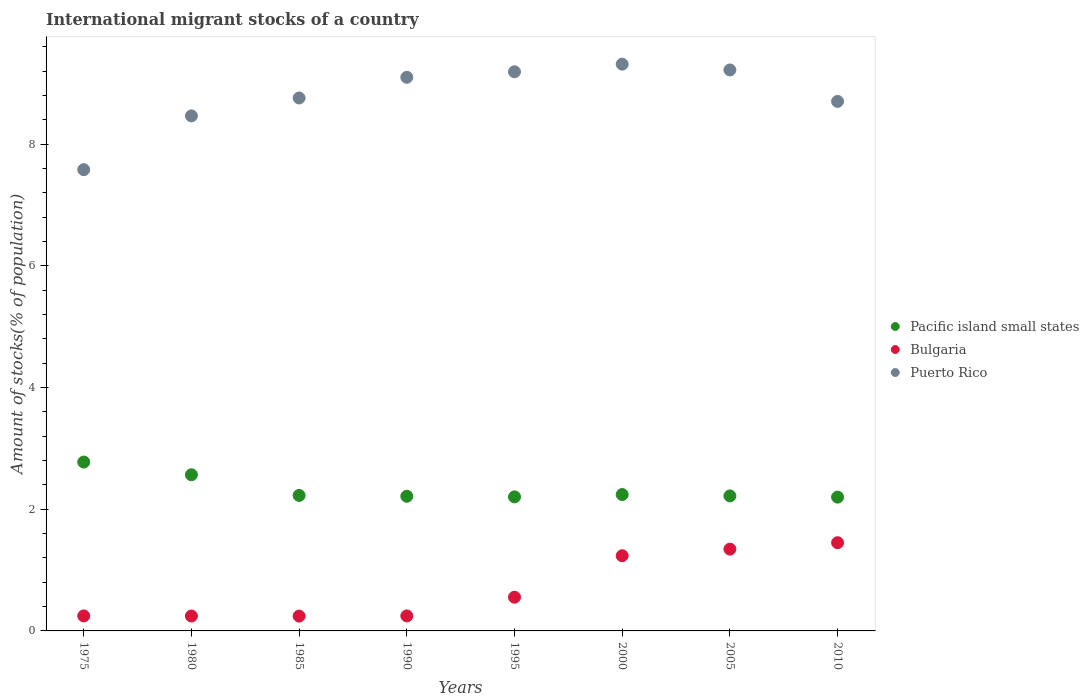How many different coloured dotlines are there?
Provide a succinct answer. 3. What is the amount of stocks in in Puerto Rico in 2000?
Give a very brief answer. 9.32. Across all years, what is the maximum amount of stocks in in Pacific island small states?
Offer a terse response. 2.78. Across all years, what is the minimum amount of stocks in in Pacific island small states?
Your response must be concise. 2.2. In which year was the amount of stocks in in Pacific island small states maximum?
Make the answer very short. 1975. In which year was the amount of stocks in in Bulgaria minimum?
Make the answer very short. 1985. What is the total amount of stocks in in Pacific island small states in the graph?
Provide a succinct answer. 18.65. What is the difference between the amount of stocks in in Puerto Rico in 1995 and that in 2005?
Ensure brevity in your answer.  -0.03. What is the difference between the amount of stocks in in Pacific island small states in 1985 and the amount of stocks in in Puerto Rico in 1995?
Your answer should be very brief. -6.96. What is the average amount of stocks in in Pacific island small states per year?
Make the answer very short. 2.33. In the year 2000, what is the difference between the amount of stocks in in Bulgaria and amount of stocks in in Puerto Rico?
Provide a succinct answer. -8.08. What is the ratio of the amount of stocks in in Puerto Rico in 1990 to that in 1995?
Your response must be concise. 0.99. Is the difference between the amount of stocks in in Bulgaria in 1995 and 2000 greater than the difference between the amount of stocks in in Puerto Rico in 1995 and 2000?
Offer a terse response. No. What is the difference between the highest and the second highest amount of stocks in in Bulgaria?
Provide a succinct answer. 0.11. What is the difference between the highest and the lowest amount of stocks in in Pacific island small states?
Offer a very short reply. 0.58. In how many years, is the amount of stocks in in Bulgaria greater than the average amount of stocks in in Bulgaria taken over all years?
Offer a very short reply. 3. Is it the case that in every year, the sum of the amount of stocks in in Puerto Rico and amount of stocks in in Bulgaria  is greater than the amount of stocks in in Pacific island small states?
Offer a terse response. Yes. Does the amount of stocks in in Puerto Rico monotonically increase over the years?
Your answer should be very brief. No. Is the amount of stocks in in Pacific island small states strictly less than the amount of stocks in in Bulgaria over the years?
Make the answer very short. No. How many dotlines are there?
Provide a succinct answer. 3. Are the values on the major ticks of Y-axis written in scientific E-notation?
Offer a terse response. No. How are the legend labels stacked?
Give a very brief answer. Vertical. What is the title of the graph?
Your response must be concise. International migrant stocks of a country. What is the label or title of the X-axis?
Make the answer very short. Years. What is the label or title of the Y-axis?
Keep it short and to the point. Amount of stocks(% of population). What is the Amount of stocks(% of population) in Pacific island small states in 1975?
Ensure brevity in your answer.  2.78. What is the Amount of stocks(% of population) of Bulgaria in 1975?
Keep it short and to the point. 0.25. What is the Amount of stocks(% of population) in Puerto Rico in 1975?
Your answer should be very brief. 7.58. What is the Amount of stocks(% of population) of Pacific island small states in 1980?
Offer a terse response. 2.57. What is the Amount of stocks(% of population) of Bulgaria in 1980?
Ensure brevity in your answer.  0.24. What is the Amount of stocks(% of population) of Puerto Rico in 1980?
Make the answer very short. 8.47. What is the Amount of stocks(% of population) in Pacific island small states in 1985?
Offer a very short reply. 2.23. What is the Amount of stocks(% of population) of Bulgaria in 1985?
Provide a succinct answer. 0.24. What is the Amount of stocks(% of population) of Puerto Rico in 1985?
Your answer should be compact. 8.76. What is the Amount of stocks(% of population) of Pacific island small states in 1990?
Give a very brief answer. 2.21. What is the Amount of stocks(% of population) in Bulgaria in 1990?
Ensure brevity in your answer.  0.25. What is the Amount of stocks(% of population) in Puerto Rico in 1990?
Your answer should be very brief. 9.1. What is the Amount of stocks(% of population) of Pacific island small states in 1995?
Provide a short and direct response. 2.2. What is the Amount of stocks(% of population) of Bulgaria in 1995?
Your answer should be very brief. 0.55. What is the Amount of stocks(% of population) of Puerto Rico in 1995?
Your answer should be very brief. 9.19. What is the Amount of stocks(% of population) of Pacific island small states in 2000?
Provide a succinct answer. 2.24. What is the Amount of stocks(% of population) of Bulgaria in 2000?
Keep it short and to the point. 1.24. What is the Amount of stocks(% of population) in Puerto Rico in 2000?
Give a very brief answer. 9.32. What is the Amount of stocks(% of population) of Pacific island small states in 2005?
Your answer should be very brief. 2.22. What is the Amount of stocks(% of population) in Bulgaria in 2005?
Your response must be concise. 1.34. What is the Amount of stocks(% of population) in Puerto Rico in 2005?
Provide a succinct answer. 9.22. What is the Amount of stocks(% of population) in Pacific island small states in 2010?
Offer a very short reply. 2.2. What is the Amount of stocks(% of population) of Bulgaria in 2010?
Keep it short and to the point. 1.45. What is the Amount of stocks(% of population) of Puerto Rico in 2010?
Give a very brief answer. 8.71. Across all years, what is the maximum Amount of stocks(% of population) in Pacific island small states?
Ensure brevity in your answer.  2.78. Across all years, what is the maximum Amount of stocks(% of population) of Bulgaria?
Your answer should be very brief. 1.45. Across all years, what is the maximum Amount of stocks(% of population) of Puerto Rico?
Your answer should be very brief. 9.32. Across all years, what is the minimum Amount of stocks(% of population) of Pacific island small states?
Ensure brevity in your answer.  2.2. Across all years, what is the minimum Amount of stocks(% of population) in Bulgaria?
Offer a terse response. 0.24. Across all years, what is the minimum Amount of stocks(% of population) in Puerto Rico?
Provide a short and direct response. 7.58. What is the total Amount of stocks(% of population) of Pacific island small states in the graph?
Ensure brevity in your answer.  18.65. What is the total Amount of stocks(% of population) of Bulgaria in the graph?
Your answer should be compact. 5.57. What is the total Amount of stocks(% of population) in Puerto Rico in the graph?
Ensure brevity in your answer.  70.35. What is the difference between the Amount of stocks(% of population) of Pacific island small states in 1975 and that in 1980?
Give a very brief answer. 0.21. What is the difference between the Amount of stocks(% of population) in Bulgaria in 1975 and that in 1980?
Keep it short and to the point. 0. What is the difference between the Amount of stocks(% of population) of Puerto Rico in 1975 and that in 1980?
Make the answer very short. -0.88. What is the difference between the Amount of stocks(% of population) in Pacific island small states in 1975 and that in 1985?
Provide a short and direct response. 0.55. What is the difference between the Amount of stocks(% of population) in Bulgaria in 1975 and that in 1985?
Keep it short and to the point. 0. What is the difference between the Amount of stocks(% of population) of Puerto Rico in 1975 and that in 1985?
Your answer should be very brief. -1.18. What is the difference between the Amount of stocks(% of population) of Pacific island small states in 1975 and that in 1990?
Provide a succinct answer. 0.56. What is the difference between the Amount of stocks(% of population) in Puerto Rico in 1975 and that in 1990?
Provide a succinct answer. -1.52. What is the difference between the Amount of stocks(% of population) in Pacific island small states in 1975 and that in 1995?
Offer a terse response. 0.57. What is the difference between the Amount of stocks(% of population) in Bulgaria in 1975 and that in 1995?
Provide a succinct answer. -0.31. What is the difference between the Amount of stocks(% of population) of Puerto Rico in 1975 and that in 1995?
Your response must be concise. -1.61. What is the difference between the Amount of stocks(% of population) in Pacific island small states in 1975 and that in 2000?
Offer a terse response. 0.53. What is the difference between the Amount of stocks(% of population) of Bulgaria in 1975 and that in 2000?
Provide a succinct answer. -0.99. What is the difference between the Amount of stocks(% of population) of Puerto Rico in 1975 and that in 2000?
Ensure brevity in your answer.  -1.73. What is the difference between the Amount of stocks(% of population) in Pacific island small states in 1975 and that in 2005?
Make the answer very short. 0.56. What is the difference between the Amount of stocks(% of population) in Bulgaria in 1975 and that in 2005?
Offer a very short reply. -1.1. What is the difference between the Amount of stocks(% of population) of Puerto Rico in 1975 and that in 2005?
Your answer should be very brief. -1.64. What is the difference between the Amount of stocks(% of population) of Pacific island small states in 1975 and that in 2010?
Offer a terse response. 0.58. What is the difference between the Amount of stocks(% of population) of Bulgaria in 1975 and that in 2010?
Offer a very short reply. -1.2. What is the difference between the Amount of stocks(% of population) of Puerto Rico in 1975 and that in 2010?
Keep it short and to the point. -1.12. What is the difference between the Amount of stocks(% of population) in Pacific island small states in 1980 and that in 1985?
Offer a terse response. 0.34. What is the difference between the Amount of stocks(% of population) of Bulgaria in 1980 and that in 1985?
Your response must be concise. 0. What is the difference between the Amount of stocks(% of population) in Puerto Rico in 1980 and that in 1985?
Your response must be concise. -0.29. What is the difference between the Amount of stocks(% of population) in Pacific island small states in 1980 and that in 1990?
Give a very brief answer. 0.35. What is the difference between the Amount of stocks(% of population) in Bulgaria in 1980 and that in 1990?
Provide a short and direct response. -0. What is the difference between the Amount of stocks(% of population) of Puerto Rico in 1980 and that in 1990?
Provide a succinct answer. -0.63. What is the difference between the Amount of stocks(% of population) of Pacific island small states in 1980 and that in 1995?
Your answer should be very brief. 0.36. What is the difference between the Amount of stocks(% of population) in Bulgaria in 1980 and that in 1995?
Offer a very short reply. -0.31. What is the difference between the Amount of stocks(% of population) of Puerto Rico in 1980 and that in 1995?
Your answer should be compact. -0.73. What is the difference between the Amount of stocks(% of population) in Pacific island small states in 1980 and that in 2000?
Provide a succinct answer. 0.33. What is the difference between the Amount of stocks(% of population) in Bulgaria in 1980 and that in 2000?
Your response must be concise. -0.99. What is the difference between the Amount of stocks(% of population) of Puerto Rico in 1980 and that in 2000?
Your answer should be very brief. -0.85. What is the difference between the Amount of stocks(% of population) of Pacific island small states in 1980 and that in 2005?
Provide a short and direct response. 0.35. What is the difference between the Amount of stocks(% of population) in Bulgaria in 1980 and that in 2005?
Keep it short and to the point. -1.1. What is the difference between the Amount of stocks(% of population) in Puerto Rico in 1980 and that in 2005?
Your answer should be compact. -0.76. What is the difference between the Amount of stocks(% of population) in Pacific island small states in 1980 and that in 2010?
Keep it short and to the point. 0.37. What is the difference between the Amount of stocks(% of population) of Bulgaria in 1980 and that in 2010?
Your answer should be compact. -1.21. What is the difference between the Amount of stocks(% of population) in Puerto Rico in 1980 and that in 2010?
Your answer should be compact. -0.24. What is the difference between the Amount of stocks(% of population) of Pacific island small states in 1985 and that in 1990?
Keep it short and to the point. 0.01. What is the difference between the Amount of stocks(% of population) of Bulgaria in 1985 and that in 1990?
Your response must be concise. -0. What is the difference between the Amount of stocks(% of population) of Puerto Rico in 1985 and that in 1990?
Provide a short and direct response. -0.34. What is the difference between the Amount of stocks(% of population) of Pacific island small states in 1985 and that in 1995?
Offer a very short reply. 0.02. What is the difference between the Amount of stocks(% of population) in Bulgaria in 1985 and that in 1995?
Ensure brevity in your answer.  -0.31. What is the difference between the Amount of stocks(% of population) in Puerto Rico in 1985 and that in 1995?
Make the answer very short. -0.43. What is the difference between the Amount of stocks(% of population) of Pacific island small states in 1985 and that in 2000?
Make the answer very short. -0.01. What is the difference between the Amount of stocks(% of population) of Bulgaria in 1985 and that in 2000?
Your answer should be very brief. -0.99. What is the difference between the Amount of stocks(% of population) in Puerto Rico in 1985 and that in 2000?
Ensure brevity in your answer.  -0.56. What is the difference between the Amount of stocks(% of population) of Pacific island small states in 1985 and that in 2005?
Your answer should be compact. 0.01. What is the difference between the Amount of stocks(% of population) in Bulgaria in 1985 and that in 2005?
Your response must be concise. -1.1. What is the difference between the Amount of stocks(% of population) in Puerto Rico in 1985 and that in 2005?
Keep it short and to the point. -0.46. What is the difference between the Amount of stocks(% of population) of Pacific island small states in 1985 and that in 2010?
Your answer should be compact. 0.03. What is the difference between the Amount of stocks(% of population) of Bulgaria in 1985 and that in 2010?
Your response must be concise. -1.21. What is the difference between the Amount of stocks(% of population) of Puerto Rico in 1985 and that in 2010?
Offer a terse response. 0.06. What is the difference between the Amount of stocks(% of population) in Pacific island small states in 1990 and that in 1995?
Keep it short and to the point. 0.01. What is the difference between the Amount of stocks(% of population) of Bulgaria in 1990 and that in 1995?
Provide a succinct answer. -0.31. What is the difference between the Amount of stocks(% of population) in Puerto Rico in 1990 and that in 1995?
Ensure brevity in your answer.  -0.09. What is the difference between the Amount of stocks(% of population) of Pacific island small states in 1990 and that in 2000?
Your response must be concise. -0.03. What is the difference between the Amount of stocks(% of population) in Bulgaria in 1990 and that in 2000?
Provide a short and direct response. -0.99. What is the difference between the Amount of stocks(% of population) of Puerto Rico in 1990 and that in 2000?
Your response must be concise. -0.22. What is the difference between the Amount of stocks(% of population) in Pacific island small states in 1990 and that in 2005?
Your answer should be very brief. -0.01. What is the difference between the Amount of stocks(% of population) in Bulgaria in 1990 and that in 2005?
Provide a short and direct response. -1.1. What is the difference between the Amount of stocks(% of population) of Puerto Rico in 1990 and that in 2005?
Your answer should be very brief. -0.12. What is the difference between the Amount of stocks(% of population) in Pacific island small states in 1990 and that in 2010?
Your answer should be very brief. 0.01. What is the difference between the Amount of stocks(% of population) in Bulgaria in 1990 and that in 2010?
Provide a short and direct response. -1.2. What is the difference between the Amount of stocks(% of population) in Puerto Rico in 1990 and that in 2010?
Keep it short and to the point. 0.4. What is the difference between the Amount of stocks(% of population) of Pacific island small states in 1995 and that in 2000?
Your answer should be very brief. -0.04. What is the difference between the Amount of stocks(% of population) in Bulgaria in 1995 and that in 2000?
Give a very brief answer. -0.68. What is the difference between the Amount of stocks(% of population) in Puerto Rico in 1995 and that in 2000?
Keep it short and to the point. -0.12. What is the difference between the Amount of stocks(% of population) of Pacific island small states in 1995 and that in 2005?
Offer a terse response. -0.02. What is the difference between the Amount of stocks(% of population) in Bulgaria in 1995 and that in 2005?
Offer a terse response. -0.79. What is the difference between the Amount of stocks(% of population) of Puerto Rico in 1995 and that in 2005?
Your response must be concise. -0.03. What is the difference between the Amount of stocks(% of population) of Pacific island small states in 1995 and that in 2010?
Keep it short and to the point. 0. What is the difference between the Amount of stocks(% of population) in Bulgaria in 1995 and that in 2010?
Offer a terse response. -0.9. What is the difference between the Amount of stocks(% of population) in Puerto Rico in 1995 and that in 2010?
Ensure brevity in your answer.  0.49. What is the difference between the Amount of stocks(% of population) in Pacific island small states in 2000 and that in 2005?
Give a very brief answer. 0.02. What is the difference between the Amount of stocks(% of population) of Bulgaria in 2000 and that in 2005?
Your response must be concise. -0.11. What is the difference between the Amount of stocks(% of population) of Puerto Rico in 2000 and that in 2005?
Give a very brief answer. 0.1. What is the difference between the Amount of stocks(% of population) in Pacific island small states in 2000 and that in 2010?
Your answer should be compact. 0.04. What is the difference between the Amount of stocks(% of population) in Bulgaria in 2000 and that in 2010?
Your answer should be compact. -0.21. What is the difference between the Amount of stocks(% of population) in Puerto Rico in 2000 and that in 2010?
Provide a short and direct response. 0.61. What is the difference between the Amount of stocks(% of population) in Pacific island small states in 2005 and that in 2010?
Offer a terse response. 0.02. What is the difference between the Amount of stocks(% of population) of Bulgaria in 2005 and that in 2010?
Offer a terse response. -0.11. What is the difference between the Amount of stocks(% of population) of Puerto Rico in 2005 and that in 2010?
Keep it short and to the point. 0.52. What is the difference between the Amount of stocks(% of population) of Pacific island small states in 1975 and the Amount of stocks(% of population) of Bulgaria in 1980?
Offer a terse response. 2.53. What is the difference between the Amount of stocks(% of population) in Pacific island small states in 1975 and the Amount of stocks(% of population) in Puerto Rico in 1980?
Provide a short and direct response. -5.69. What is the difference between the Amount of stocks(% of population) in Bulgaria in 1975 and the Amount of stocks(% of population) in Puerto Rico in 1980?
Your response must be concise. -8.22. What is the difference between the Amount of stocks(% of population) of Pacific island small states in 1975 and the Amount of stocks(% of population) of Bulgaria in 1985?
Your answer should be very brief. 2.53. What is the difference between the Amount of stocks(% of population) of Pacific island small states in 1975 and the Amount of stocks(% of population) of Puerto Rico in 1985?
Offer a terse response. -5.99. What is the difference between the Amount of stocks(% of population) in Bulgaria in 1975 and the Amount of stocks(% of population) in Puerto Rico in 1985?
Provide a succinct answer. -8.51. What is the difference between the Amount of stocks(% of population) of Pacific island small states in 1975 and the Amount of stocks(% of population) of Bulgaria in 1990?
Give a very brief answer. 2.53. What is the difference between the Amount of stocks(% of population) of Pacific island small states in 1975 and the Amount of stocks(% of population) of Puerto Rico in 1990?
Keep it short and to the point. -6.33. What is the difference between the Amount of stocks(% of population) of Bulgaria in 1975 and the Amount of stocks(% of population) of Puerto Rico in 1990?
Provide a succinct answer. -8.85. What is the difference between the Amount of stocks(% of population) in Pacific island small states in 1975 and the Amount of stocks(% of population) in Bulgaria in 1995?
Offer a terse response. 2.22. What is the difference between the Amount of stocks(% of population) in Pacific island small states in 1975 and the Amount of stocks(% of population) in Puerto Rico in 1995?
Ensure brevity in your answer.  -6.42. What is the difference between the Amount of stocks(% of population) in Bulgaria in 1975 and the Amount of stocks(% of population) in Puerto Rico in 1995?
Provide a short and direct response. -8.95. What is the difference between the Amount of stocks(% of population) in Pacific island small states in 1975 and the Amount of stocks(% of population) in Bulgaria in 2000?
Offer a terse response. 1.54. What is the difference between the Amount of stocks(% of population) in Pacific island small states in 1975 and the Amount of stocks(% of population) in Puerto Rico in 2000?
Your answer should be compact. -6.54. What is the difference between the Amount of stocks(% of population) of Bulgaria in 1975 and the Amount of stocks(% of population) of Puerto Rico in 2000?
Keep it short and to the point. -9.07. What is the difference between the Amount of stocks(% of population) in Pacific island small states in 1975 and the Amount of stocks(% of population) in Bulgaria in 2005?
Keep it short and to the point. 1.43. What is the difference between the Amount of stocks(% of population) in Pacific island small states in 1975 and the Amount of stocks(% of population) in Puerto Rico in 2005?
Keep it short and to the point. -6.45. What is the difference between the Amount of stocks(% of population) of Bulgaria in 1975 and the Amount of stocks(% of population) of Puerto Rico in 2005?
Keep it short and to the point. -8.98. What is the difference between the Amount of stocks(% of population) of Pacific island small states in 1975 and the Amount of stocks(% of population) of Bulgaria in 2010?
Provide a succinct answer. 1.33. What is the difference between the Amount of stocks(% of population) in Pacific island small states in 1975 and the Amount of stocks(% of population) in Puerto Rico in 2010?
Provide a succinct answer. -5.93. What is the difference between the Amount of stocks(% of population) in Bulgaria in 1975 and the Amount of stocks(% of population) in Puerto Rico in 2010?
Ensure brevity in your answer.  -8.46. What is the difference between the Amount of stocks(% of population) in Pacific island small states in 1980 and the Amount of stocks(% of population) in Bulgaria in 1985?
Your answer should be compact. 2.32. What is the difference between the Amount of stocks(% of population) in Pacific island small states in 1980 and the Amount of stocks(% of population) in Puerto Rico in 1985?
Your response must be concise. -6.19. What is the difference between the Amount of stocks(% of population) of Bulgaria in 1980 and the Amount of stocks(% of population) of Puerto Rico in 1985?
Give a very brief answer. -8.52. What is the difference between the Amount of stocks(% of population) in Pacific island small states in 1980 and the Amount of stocks(% of population) in Bulgaria in 1990?
Provide a succinct answer. 2.32. What is the difference between the Amount of stocks(% of population) of Pacific island small states in 1980 and the Amount of stocks(% of population) of Puerto Rico in 1990?
Offer a terse response. -6.53. What is the difference between the Amount of stocks(% of population) in Bulgaria in 1980 and the Amount of stocks(% of population) in Puerto Rico in 1990?
Your response must be concise. -8.86. What is the difference between the Amount of stocks(% of population) in Pacific island small states in 1980 and the Amount of stocks(% of population) in Bulgaria in 1995?
Offer a terse response. 2.01. What is the difference between the Amount of stocks(% of population) in Pacific island small states in 1980 and the Amount of stocks(% of population) in Puerto Rico in 1995?
Provide a succinct answer. -6.62. What is the difference between the Amount of stocks(% of population) in Bulgaria in 1980 and the Amount of stocks(% of population) in Puerto Rico in 1995?
Keep it short and to the point. -8.95. What is the difference between the Amount of stocks(% of population) in Pacific island small states in 1980 and the Amount of stocks(% of population) in Bulgaria in 2000?
Offer a terse response. 1.33. What is the difference between the Amount of stocks(% of population) in Pacific island small states in 1980 and the Amount of stocks(% of population) in Puerto Rico in 2000?
Make the answer very short. -6.75. What is the difference between the Amount of stocks(% of population) in Bulgaria in 1980 and the Amount of stocks(% of population) in Puerto Rico in 2000?
Offer a terse response. -9.07. What is the difference between the Amount of stocks(% of population) of Pacific island small states in 1980 and the Amount of stocks(% of population) of Bulgaria in 2005?
Offer a very short reply. 1.22. What is the difference between the Amount of stocks(% of population) in Pacific island small states in 1980 and the Amount of stocks(% of population) in Puerto Rico in 2005?
Your answer should be very brief. -6.65. What is the difference between the Amount of stocks(% of population) in Bulgaria in 1980 and the Amount of stocks(% of population) in Puerto Rico in 2005?
Your answer should be compact. -8.98. What is the difference between the Amount of stocks(% of population) in Pacific island small states in 1980 and the Amount of stocks(% of population) in Bulgaria in 2010?
Make the answer very short. 1.12. What is the difference between the Amount of stocks(% of population) in Pacific island small states in 1980 and the Amount of stocks(% of population) in Puerto Rico in 2010?
Your response must be concise. -6.14. What is the difference between the Amount of stocks(% of population) in Bulgaria in 1980 and the Amount of stocks(% of population) in Puerto Rico in 2010?
Make the answer very short. -8.46. What is the difference between the Amount of stocks(% of population) of Pacific island small states in 1985 and the Amount of stocks(% of population) of Bulgaria in 1990?
Provide a succinct answer. 1.98. What is the difference between the Amount of stocks(% of population) in Pacific island small states in 1985 and the Amount of stocks(% of population) in Puerto Rico in 1990?
Offer a terse response. -6.87. What is the difference between the Amount of stocks(% of population) of Bulgaria in 1985 and the Amount of stocks(% of population) of Puerto Rico in 1990?
Your answer should be very brief. -8.86. What is the difference between the Amount of stocks(% of population) of Pacific island small states in 1985 and the Amount of stocks(% of population) of Bulgaria in 1995?
Your answer should be very brief. 1.67. What is the difference between the Amount of stocks(% of population) of Pacific island small states in 1985 and the Amount of stocks(% of population) of Puerto Rico in 1995?
Your answer should be compact. -6.96. What is the difference between the Amount of stocks(% of population) of Bulgaria in 1985 and the Amount of stocks(% of population) of Puerto Rico in 1995?
Provide a short and direct response. -8.95. What is the difference between the Amount of stocks(% of population) in Pacific island small states in 1985 and the Amount of stocks(% of population) in Puerto Rico in 2000?
Your response must be concise. -7.09. What is the difference between the Amount of stocks(% of population) of Bulgaria in 1985 and the Amount of stocks(% of population) of Puerto Rico in 2000?
Your answer should be very brief. -9.07. What is the difference between the Amount of stocks(% of population) in Pacific island small states in 1985 and the Amount of stocks(% of population) in Bulgaria in 2005?
Your answer should be very brief. 0.88. What is the difference between the Amount of stocks(% of population) in Pacific island small states in 1985 and the Amount of stocks(% of population) in Puerto Rico in 2005?
Your answer should be very brief. -6.99. What is the difference between the Amount of stocks(% of population) of Bulgaria in 1985 and the Amount of stocks(% of population) of Puerto Rico in 2005?
Ensure brevity in your answer.  -8.98. What is the difference between the Amount of stocks(% of population) of Pacific island small states in 1985 and the Amount of stocks(% of population) of Bulgaria in 2010?
Provide a short and direct response. 0.78. What is the difference between the Amount of stocks(% of population) in Pacific island small states in 1985 and the Amount of stocks(% of population) in Puerto Rico in 2010?
Offer a very short reply. -6.48. What is the difference between the Amount of stocks(% of population) of Bulgaria in 1985 and the Amount of stocks(% of population) of Puerto Rico in 2010?
Provide a succinct answer. -8.46. What is the difference between the Amount of stocks(% of population) in Pacific island small states in 1990 and the Amount of stocks(% of population) in Bulgaria in 1995?
Your response must be concise. 1.66. What is the difference between the Amount of stocks(% of population) in Pacific island small states in 1990 and the Amount of stocks(% of population) in Puerto Rico in 1995?
Provide a succinct answer. -6.98. What is the difference between the Amount of stocks(% of population) in Bulgaria in 1990 and the Amount of stocks(% of population) in Puerto Rico in 1995?
Your response must be concise. -8.95. What is the difference between the Amount of stocks(% of population) in Pacific island small states in 1990 and the Amount of stocks(% of population) in Bulgaria in 2000?
Your response must be concise. 0.98. What is the difference between the Amount of stocks(% of population) of Pacific island small states in 1990 and the Amount of stocks(% of population) of Puerto Rico in 2000?
Keep it short and to the point. -7.1. What is the difference between the Amount of stocks(% of population) in Bulgaria in 1990 and the Amount of stocks(% of population) in Puerto Rico in 2000?
Make the answer very short. -9.07. What is the difference between the Amount of stocks(% of population) in Pacific island small states in 1990 and the Amount of stocks(% of population) in Bulgaria in 2005?
Give a very brief answer. 0.87. What is the difference between the Amount of stocks(% of population) of Pacific island small states in 1990 and the Amount of stocks(% of population) of Puerto Rico in 2005?
Offer a very short reply. -7.01. What is the difference between the Amount of stocks(% of population) of Bulgaria in 1990 and the Amount of stocks(% of population) of Puerto Rico in 2005?
Give a very brief answer. -8.98. What is the difference between the Amount of stocks(% of population) in Pacific island small states in 1990 and the Amount of stocks(% of population) in Bulgaria in 2010?
Ensure brevity in your answer.  0.76. What is the difference between the Amount of stocks(% of population) in Pacific island small states in 1990 and the Amount of stocks(% of population) in Puerto Rico in 2010?
Your answer should be very brief. -6.49. What is the difference between the Amount of stocks(% of population) of Bulgaria in 1990 and the Amount of stocks(% of population) of Puerto Rico in 2010?
Ensure brevity in your answer.  -8.46. What is the difference between the Amount of stocks(% of population) in Pacific island small states in 1995 and the Amount of stocks(% of population) in Bulgaria in 2000?
Keep it short and to the point. 0.97. What is the difference between the Amount of stocks(% of population) in Pacific island small states in 1995 and the Amount of stocks(% of population) in Puerto Rico in 2000?
Make the answer very short. -7.11. What is the difference between the Amount of stocks(% of population) in Bulgaria in 1995 and the Amount of stocks(% of population) in Puerto Rico in 2000?
Your answer should be very brief. -8.76. What is the difference between the Amount of stocks(% of population) in Pacific island small states in 1995 and the Amount of stocks(% of population) in Bulgaria in 2005?
Keep it short and to the point. 0.86. What is the difference between the Amount of stocks(% of population) in Pacific island small states in 1995 and the Amount of stocks(% of population) in Puerto Rico in 2005?
Your response must be concise. -7.02. What is the difference between the Amount of stocks(% of population) of Bulgaria in 1995 and the Amount of stocks(% of population) of Puerto Rico in 2005?
Ensure brevity in your answer.  -8.67. What is the difference between the Amount of stocks(% of population) of Pacific island small states in 1995 and the Amount of stocks(% of population) of Bulgaria in 2010?
Keep it short and to the point. 0.75. What is the difference between the Amount of stocks(% of population) in Pacific island small states in 1995 and the Amount of stocks(% of population) in Puerto Rico in 2010?
Ensure brevity in your answer.  -6.5. What is the difference between the Amount of stocks(% of population) of Bulgaria in 1995 and the Amount of stocks(% of population) of Puerto Rico in 2010?
Offer a very short reply. -8.15. What is the difference between the Amount of stocks(% of population) of Pacific island small states in 2000 and the Amount of stocks(% of population) of Bulgaria in 2005?
Offer a very short reply. 0.9. What is the difference between the Amount of stocks(% of population) of Pacific island small states in 2000 and the Amount of stocks(% of population) of Puerto Rico in 2005?
Make the answer very short. -6.98. What is the difference between the Amount of stocks(% of population) of Bulgaria in 2000 and the Amount of stocks(% of population) of Puerto Rico in 2005?
Your answer should be very brief. -7.99. What is the difference between the Amount of stocks(% of population) of Pacific island small states in 2000 and the Amount of stocks(% of population) of Bulgaria in 2010?
Your answer should be compact. 0.79. What is the difference between the Amount of stocks(% of population) of Pacific island small states in 2000 and the Amount of stocks(% of population) of Puerto Rico in 2010?
Your answer should be compact. -6.46. What is the difference between the Amount of stocks(% of population) in Bulgaria in 2000 and the Amount of stocks(% of population) in Puerto Rico in 2010?
Your response must be concise. -7.47. What is the difference between the Amount of stocks(% of population) in Pacific island small states in 2005 and the Amount of stocks(% of population) in Bulgaria in 2010?
Ensure brevity in your answer.  0.77. What is the difference between the Amount of stocks(% of population) of Pacific island small states in 2005 and the Amount of stocks(% of population) of Puerto Rico in 2010?
Keep it short and to the point. -6.49. What is the difference between the Amount of stocks(% of population) of Bulgaria in 2005 and the Amount of stocks(% of population) of Puerto Rico in 2010?
Offer a terse response. -7.36. What is the average Amount of stocks(% of population) of Pacific island small states per year?
Keep it short and to the point. 2.33. What is the average Amount of stocks(% of population) in Bulgaria per year?
Offer a terse response. 0.7. What is the average Amount of stocks(% of population) of Puerto Rico per year?
Keep it short and to the point. 8.79. In the year 1975, what is the difference between the Amount of stocks(% of population) of Pacific island small states and Amount of stocks(% of population) of Bulgaria?
Make the answer very short. 2.53. In the year 1975, what is the difference between the Amount of stocks(% of population) of Pacific island small states and Amount of stocks(% of population) of Puerto Rico?
Offer a very short reply. -4.81. In the year 1975, what is the difference between the Amount of stocks(% of population) of Bulgaria and Amount of stocks(% of population) of Puerto Rico?
Provide a succinct answer. -7.34. In the year 1980, what is the difference between the Amount of stocks(% of population) of Pacific island small states and Amount of stocks(% of population) of Bulgaria?
Make the answer very short. 2.32. In the year 1980, what is the difference between the Amount of stocks(% of population) in Pacific island small states and Amount of stocks(% of population) in Puerto Rico?
Keep it short and to the point. -5.9. In the year 1980, what is the difference between the Amount of stocks(% of population) in Bulgaria and Amount of stocks(% of population) in Puerto Rico?
Offer a terse response. -8.22. In the year 1985, what is the difference between the Amount of stocks(% of population) of Pacific island small states and Amount of stocks(% of population) of Bulgaria?
Give a very brief answer. 1.98. In the year 1985, what is the difference between the Amount of stocks(% of population) of Pacific island small states and Amount of stocks(% of population) of Puerto Rico?
Give a very brief answer. -6.53. In the year 1985, what is the difference between the Amount of stocks(% of population) of Bulgaria and Amount of stocks(% of population) of Puerto Rico?
Ensure brevity in your answer.  -8.52. In the year 1990, what is the difference between the Amount of stocks(% of population) in Pacific island small states and Amount of stocks(% of population) in Bulgaria?
Your answer should be very brief. 1.97. In the year 1990, what is the difference between the Amount of stocks(% of population) of Pacific island small states and Amount of stocks(% of population) of Puerto Rico?
Keep it short and to the point. -6.89. In the year 1990, what is the difference between the Amount of stocks(% of population) in Bulgaria and Amount of stocks(% of population) in Puerto Rico?
Your answer should be compact. -8.85. In the year 1995, what is the difference between the Amount of stocks(% of population) of Pacific island small states and Amount of stocks(% of population) of Bulgaria?
Your answer should be very brief. 1.65. In the year 1995, what is the difference between the Amount of stocks(% of population) of Pacific island small states and Amount of stocks(% of population) of Puerto Rico?
Your response must be concise. -6.99. In the year 1995, what is the difference between the Amount of stocks(% of population) of Bulgaria and Amount of stocks(% of population) of Puerto Rico?
Your response must be concise. -8.64. In the year 2000, what is the difference between the Amount of stocks(% of population) in Pacific island small states and Amount of stocks(% of population) in Bulgaria?
Give a very brief answer. 1.01. In the year 2000, what is the difference between the Amount of stocks(% of population) in Pacific island small states and Amount of stocks(% of population) in Puerto Rico?
Offer a very short reply. -7.08. In the year 2000, what is the difference between the Amount of stocks(% of population) in Bulgaria and Amount of stocks(% of population) in Puerto Rico?
Provide a short and direct response. -8.08. In the year 2005, what is the difference between the Amount of stocks(% of population) of Pacific island small states and Amount of stocks(% of population) of Bulgaria?
Your answer should be very brief. 0.87. In the year 2005, what is the difference between the Amount of stocks(% of population) in Pacific island small states and Amount of stocks(% of population) in Puerto Rico?
Your response must be concise. -7. In the year 2005, what is the difference between the Amount of stocks(% of population) of Bulgaria and Amount of stocks(% of population) of Puerto Rico?
Offer a terse response. -7.88. In the year 2010, what is the difference between the Amount of stocks(% of population) in Pacific island small states and Amount of stocks(% of population) in Bulgaria?
Give a very brief answer. 0.75. In the year 2010, what is the difference between the Amount of stocks(% of population) of Pacific island small states and Amount of stocks(% of population) of Puerto Rico?
Provide a succinct answer. -6.51. In the year 2010, what is the difference between the Amount of stocks(% of population) of Bulgaria and Amount of stocks(% of population) of Puerto Rico?
Your response must be concise. -7.25. What is the ratio of the Amount of stocks(% of population) in Pacific island small states in 1975 to that in 1980?
Your response must be concise. 1.08. What is the ratio of the Amount of stocks(% of population) of Bulgaria in 1975 to that in 1980?
Provide a short and direct response. 1.01. What is the ratio of the Amount of stocks(% of population) in Puerto Rico in 1975 to that in 1980?
Offer a very short reply. 0.9. What is the ratio of the Amount of stocks(% of population) in Pacific island small states in 1975 to that in 1985?
Offer a very short reply. 1.25. What is the ratio of the Amount of stocks(% of population) of Bulgaria in 1975 to that in 1985?
Provide a succinct answer. 1.01. What is the ratio of the Amount of stocks(% of population) of Puerto Rico in 1975 to that in 1985?
Keep it short and to the point. 0.87. What is the ratio of the Amount of stocks(% of population) of Pacific island small states in 1975 to that in 1990?
Keep it short and to the point. 1.25. What is the ratio of the Amount of stocks(% of population) in Bulgaria in 1975 to that in 1990?
Make the answer very short. 1. What is the ratio of the Amount of stocks(% of population) of Puerto Rico in 1975 to that in 1990?
Offer a terse response. 0.83. What is the ratio of the Amount of stocks(% of population) in Pacific island small states in 1975 to that in 1995?
Keep it short and to the point. 1.26. What is the ratio of the Amount of stocks(% of population) in Bulgaria in 1975 to that in 1995?
Offer a terse response. 0.44. What is the ratio of the Amount of stocks(% of population) of Puerto Rico in 1975 to that in 1995?
Keep it short and to the point. 0.82. What is the ratio of the Amount of stocks(% of population) in Pacific island small states in 1975 to that in 2000?
Your response must be concise. 1.24. What is the ratio of the Amount of stocks(% of population) in Bulgaria in 1975 to that in 2000?
Ensure brevity in your answer.  0.2. What is the ratio of the Amount of stocks(% of population) of Puerto Rico in 1975 to that in 2000?
Give a very brief answer. 0.81. What is the ratio of the Amount of stocks(% of population) of Pacific island small states in 1975 to that in 2005?
Provide a short and direct response. 1.25. What is the ratio of the Amount of stocks(% of population) of Bulgaria in 1975 to that in 2005?
Offer a very short reply. 0.18. What is the ratio of the Amount of stocks(% of population) in Puerto Rico in 1975 to that in 2005?
Keep it short and to the point. 0.82. What is the ratio of the Amount of stocks(% of population) of Pacific island small states in 1975 to that in 2010?
Your response must be concise. 1.26. What is the ratio of the Amount of stocks(% of population) of Bulgaria in 1975 to that in 2010?
Ensure brevity in your answer.  0.17. What is the ratio of the Amount of stocks(% of population) in Puerto Rico in 1975 to that in 2010?
Offer a terse response. 0.87. What is the ratio of the Amount of stocks(% of population) in Pacific island small states in 1980 to that in 1985?
Provide a short and direct response. 1.15. What is the ratio of the Amount of stocks(% of population) in Bulgaria in 1980 to that in 1985?
Keep it short and to the point. 1. What is the ratio of the Amount of stocks(% of population) of Puerto Rico in 1980 to that in 1985?
Your response must be concise. 0.97. What is the ratio of the Amount of stocks(% of population) in Pacific island small states in 1980 to that in 1990?
Keep it short and to the point. 1.16. What is the ratio of the Amount of stocks(% of population) of Bulgaria in 1980 to that in 1990?
Make the answer very short. 0.99. What is the ratio of the Amount of stocks(% of population) of Puerto Rico in 1980 to that in 1990?
Ensure brevity in your answer.  0.93. What is the ratio of the Amount of stocks(% of population) in Pacific island small states in 1980 to that in 1995?
Keep it short and to the point. 1.16. What is the ratio of the Amount of stocks(% of population) in Bulgaria in 1980 to that in 1995?
Keep it short and to the point. 0.44. What is the ratio of the Amount of stocks(% of population) of Puerto Rico in 1980 to that in 1995?
Make the answer very short. 0.92. What is the ratio of the Amount of stocks(% of population) in Pacific island small states in 1980 to that in 2000?
Make the answer very short. 1.15. What is the ratio of the Amount of stocks(% of population) of Bulgaria in 1980 to that in 2000?
Provide a succinct answer. 0.2. What is the ratio of the Amount of stocks(% of population) in Puerto Rico in 1980 to that in 2000?
Provide a succinct answer. 0.91. What is the ratio of the Amount of stocks(% of population) of Pacific island small states in 1980 to that in 2005?
Your answer should be compact. 1.16. What is the ratio of the Amount of stocks(% of population) of Bulgaria in 1980 to that in 2005?
Offer a very short reply. 0.18. What is the ratio of the Amount of stocks(% of population) of Puerto Rico in 1980 to that in 2005?
Ensure brevity in your answer.  0.92. What is the ratio of the Amount of stocks(% of population) of Pacific island small states in 1980 to that in 2010?
Keep it short and to the point. 1.17. What is the ratio of the Amount of stocks(% of population) of Bulgaria in 1980 to that in 2010?
Your response must be concise. 0.17. What is the ratio of the Amount of stocks(% of population) of Puerto Rico in 1980 to that in 2010?
Your answer should be compact. 0.97. What is the ratio of the Amount of stocks(% of population) in Puerto Rico in 1985 to that in 1990?
Provide a succinct answer. 0.96. What is the ratio of the Amount of stocks(% of population) of Pacific island small states in 1985 to that in 1995?
Ensure brevity in your answer.  1.01. What is the ratio of the Amount of stocks(% of population) in Bulgaria in 1985 to that in 1995?
Ensure brevity in your answer.  0.44. What is the ratio of the Amount of stocks(% of population) in Puerto Rico in 1985 to that in 1995?
Offer a terse response. 0.95. What is the ratio of the Amount of stocks(% of population) of Bulgaria in 1985 to that in 2000?
Offer a terse response. 0.2. What is the ratio of the Amount of stocks(% of population) of Puerto Rico in 1985 to that in 2000?
Offer a terse response. 0.94. What is the ratio of the Amount of stocks(% of population) in Pacific island small states in 1985 to that in 2005?
Offer a very short reply. 1. What is the ratio of the Amount of stocks(% of population) of Bulgaria in 1985 to that in 2005?
Keep it short and to the point. 0.18. What is the ratio of the Amount of stocks(% of population) in Puerto Rico in 1985 to that in 2005?
Offer a very short reply. 0.95. What is the ratio of the Amount of stocks(% of population) of Pacific island small states in 1985 to that in 2010?
Offer a very short reply. 1.01. What is the ratio of the Amount of stocks(% of population) in Bulgaria in 1985 to that in 2010?
Offer a terse response. 0.17. What is the ratio of the Amount of stocks(% of population) of Pacific island small states in 1990 to that in 1995?
Make the answer very short. 1. What is the ratio of the Amount of stocks(% of population) in Bulgaria in 1990 to that in 1995?
Keep it short and to the point. 0.45. What is the ratio of the Amount of stocks(% of population) of Puerto Rico in 1990 to that in 1995?
Ensure brevity in your answer.  0.99. What is the ratio of the Amount of stocks(% of population) of Pacific island small states in 1990 to that in 2000?
Give a very brief answer. 0.99. What is the ratio of the Amount of stocks(% of population) in Bulgaria in 1990 to that in 2000?
Ensure brevity in your answer.  0.2. What is the ratio of the Amount of stocks(% of population) of Puerto Rico in 1990 to that in 2000?
Make the answer very short. 0.98. What is the ratio of the Amount of stocks(% of population) in Bulgaria in 1990 to that in 2005?
Your response must be concise. 0.18. What is the ratio of the Amount of stocks(% of population) in Puerto Rico in 1990 to that in 2005?
Keep it short and to the point. 0.99. What is the ratio of the Amount of stocks(% of population) of Pacific island small states in 1990 to that in 2010?
Ensure brevity in your answer.  1.01. What is the ratio of the Amount of stocks(% of population) of Bulgaria in 1990 to that in 2010?
Give a very brief answer. 0.17. What is the ratio of the Amount of stocks(% of population) in Puerto Rico in 1990 to that in 2010?
Make the answer very short. 1.05. What is the ratio of the Amount of stocks(% of population) of Pacific island small states in 1995 to that in 2000?
Provide a short and direct response. 0.98. What is the ratio of the Amount of stocks(% of population) of Bulgaria in 1995 to that in 2000?
Provide a succinct answer. 0.45. What is the ratio of the Amount of stocks(% of population) of Puerto Rico in 1995 to that in 2000?
Provide a succinct answer. 0.99. What is the ratio of the Amount of stocks(% of population) of Bulgaria in 1995 to that in 2005?
Make the answer very short. 0.41. What is the ratio of the Amount of stocks(% of population) of Puerto Rico in 1995 to that in 2005?
Offer a terse response. 1. What is the ratio of the Amount of stocks(% of population) of Bulgaria in 1995 to that in 2010?
Provide a short and direct response. 0.38. What is the ratio of the Amount of stocks(% of population) of Puerto Rico in 1995 to that in 2010?
Keep it short and to the point. 1.06. What is the ratio of the Amount of stocks(% of population) in Pacific island small states in 2000 to that in 2005?
Your answer should be very brief. 1.01. What is the ratio of the Amount of stocks(% of population) of Bulgaria in 2000 to that in 2005?
Keep it short and to the point. 0.92. What is the ratio of the Amount of stocks(% of population) of Puerto Rico in 2000 to that in 2005?
Give a very brief answer. 1.01. What is the ratio of the Amount of stocks(% of population) in Pacific island small states in 2000 to that in 2010?
Keep it short and to the point. 1.02. What is the ratio of the Amount of stocks(% of population) in Bulgaria in 2000 to that in 2010?
Make the answer very short. 0.85. What is the ratio of the Amount of stocks(% of population) in Puerto Rico in 2000 to that in 2010?
Provide a succinct answer. 1.07. What is the ratio of the Amount of stocks(% of population) of Pacific island small states in 2005 to that in 2010?
Your response must be concise. 1.01. What is the ratio of the Amount of stocks(% of population) of Bulgaria in 2005 to that in 2010?
Ensure brevity in your answer.  0.93. What is the ratio of the Amount of stocks(% of population) in Puerto Rico in 2005 to that in 2010?
Your response must be concise. 1.06. What is the difference between the highest and the second highest Amount of stocks(% of population) in Pacific island small states?
Your response must be concise. 0.21. What is the difference between the highest and the second highest Amount of stocks(% of population) of Bulgaria?
Keep it short and to the point. 0.11. What is the difference between the highest and the second highest Amount of stocks(% of population) in Puerto Rico?
Offer a terse response. 0.1. What is the difference between the highest and the lowest Amount of stocks(% of population) in Pacific island small states?
Keep it short and to the point. 0.58. What is the difference between the highest and the lowest Amount of stocks(% of population) in Bulgaria?
Your answer should be compact. 1.21. What is the difference between the highest and the lowest Amount of stocks(% of population) of Puerto Rico?
Give a very brief answer. 1.73. 